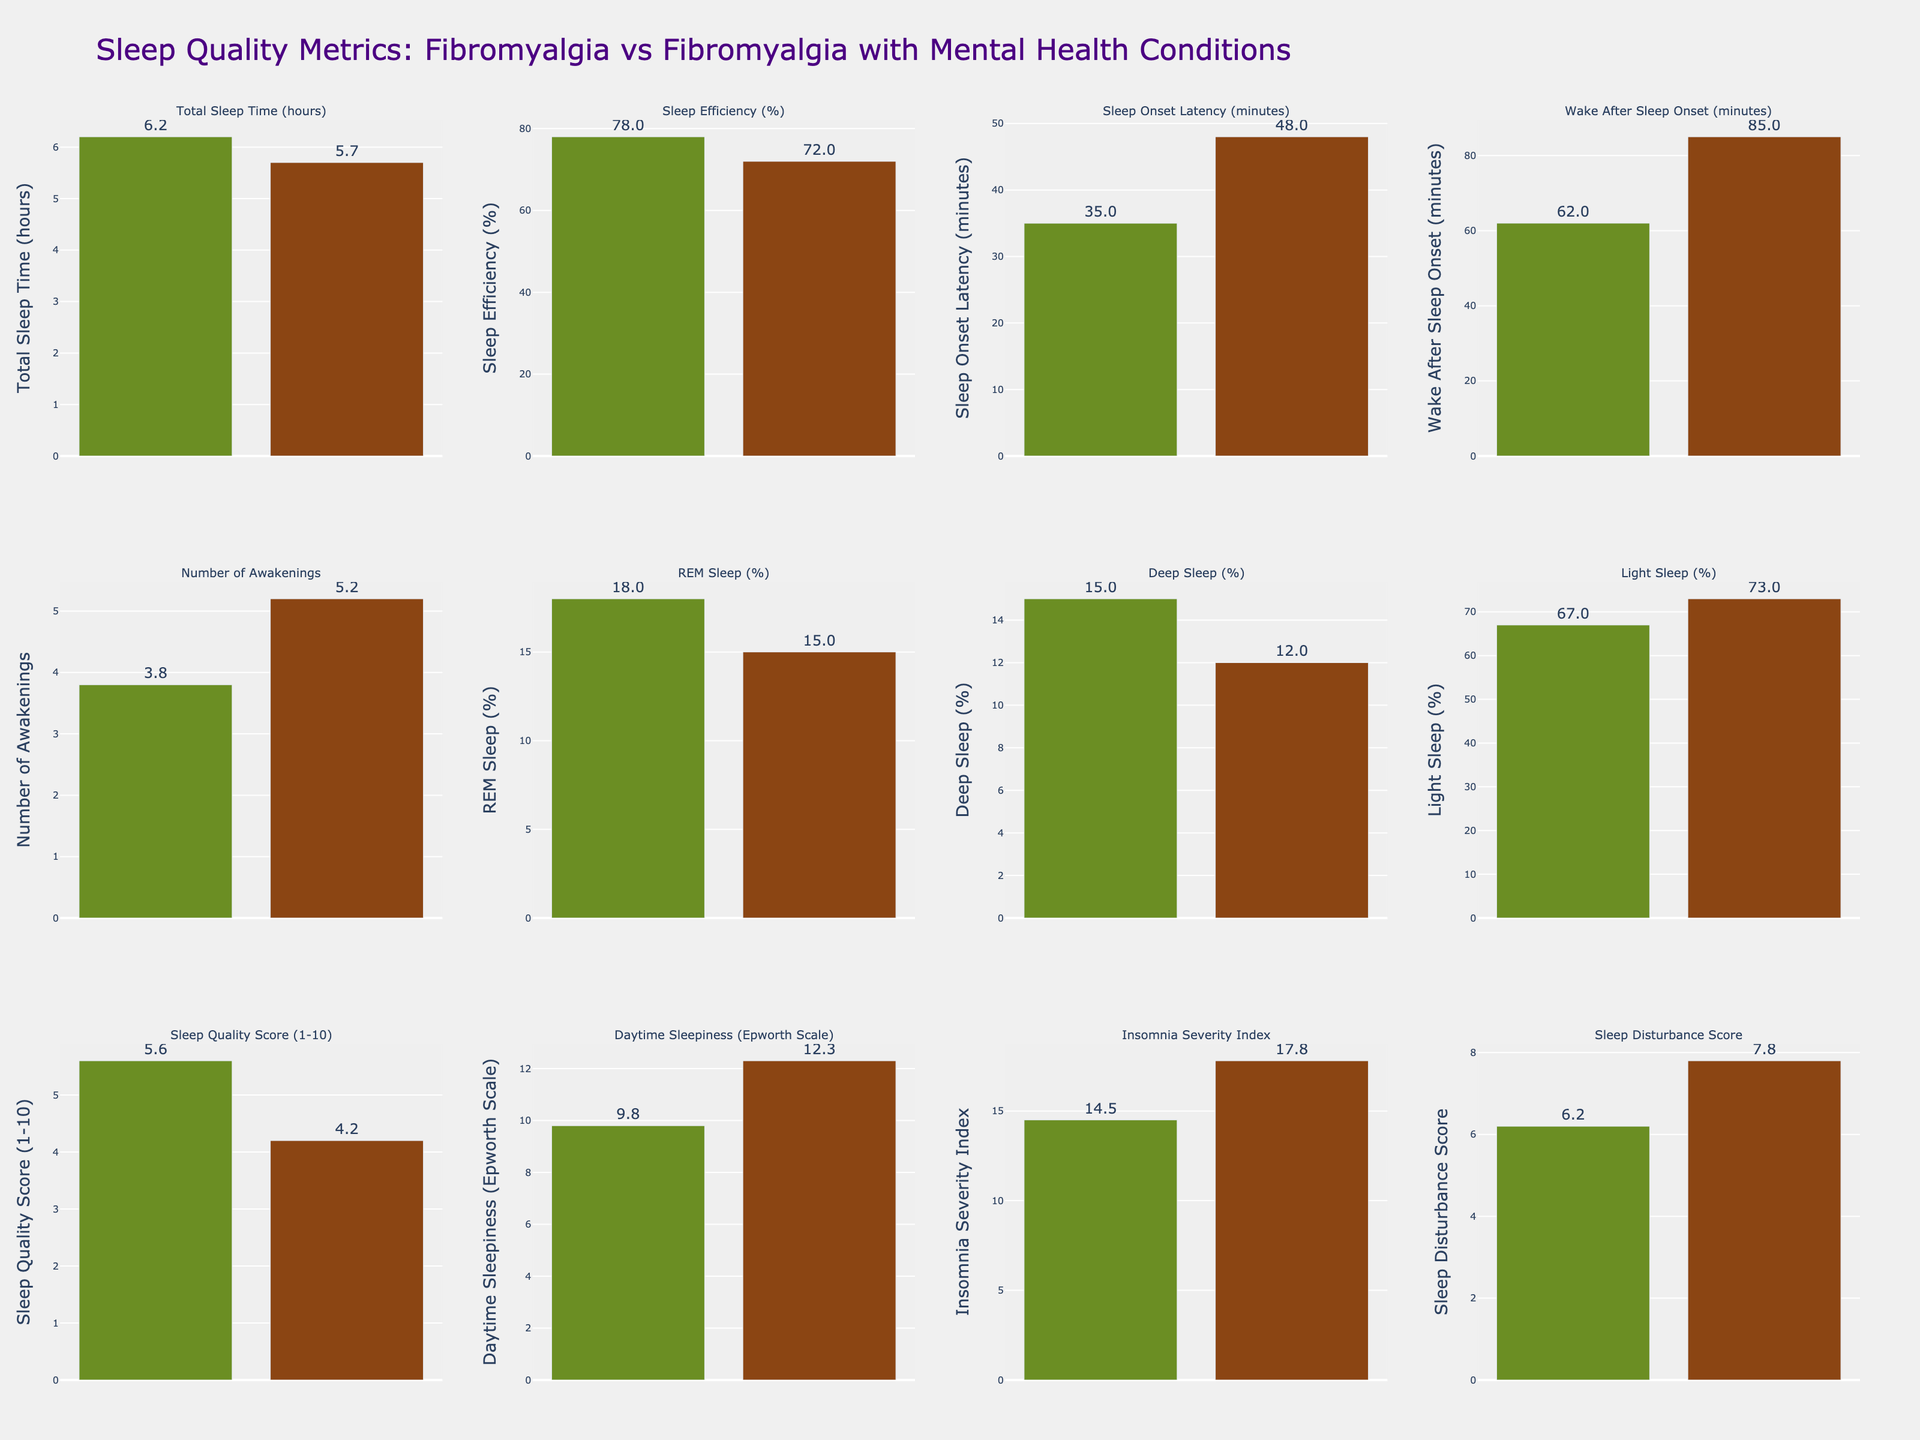Which group reports a higher Sleep Quality Score? By comparing the height of the bars for the Sleep Quality Score, the Fibromyalgia Only group has a higher value than the group with comorbid mental health conditions.
Answer: Fibromyalgia Only How much greater is the average number of awakenings in the comorbid mental health conditions group compared to the fibromyalgia only group? Subtract the number of awakenings for the Fibromyalgia Only group (3.8) from the number in the comorbid mental health conditions group (5.2).
Answer: 1.4 What is the percentage difference in Sleep Efficiency between the two groups? Calculate the difference in Sleep Efficiency (78% - 72%) and divide by the value for Fibromyalgia Only, then multiply by 100.  (78 - 72) / 78 * 100 = 7.69
Answer: 7.69% Which group has a lower percentage of REM Sleep? By comparing the heights of the bars for REM Sleep, the Fibromyalgia with comorbid mental health conditions group has a lower value.
Answer: Fibromyalgia with comorbid mental health conditions Is there a notable difference in total sleep time between the two groups? The total sleep time for Fibromyalgia Only is 6.2 hours, and for the comorbid mental health condition group it is 5.7 hours. The difference is 0.5 hours.
Answer: Yes Are there any sleep quality metrics where the two groups have equal values? Review each metric’s bars to see if they are of equal height. There are no metrics where the two groups have equal values.
Answer: No Which group experiences higher daytime sleepiness according to the Epworth Scale? The bar representing Daytime Sleepiness (Epworth Scale) shows a higher value for the comorbid mental health conditions group.
Answer: Fibromyalgia with comorbid mental health conditions What's the sum of the Insomnia Severity Index values for both groups? Add the Insomnia Severity Index for Fibromyalgia Only (14.5) and the comorbid mental health condition group (17.8). 14.5 + 17.8 = 32.3
Answer: 32.3 How many more minutes of Wake After Sleep Onset do patients with comorbid mental health conditions experience compared to those with only fibromyalgia? Subtract the Wake After Sleep Onset minutes for Fibromyalgia Only (62) from the value for comorbid mental health conditions (85). 85 - 62 = 23
Answer: 23 minutes Which metric shows the greatest difference between the two groups? By visually inspecting all the bars, Sleep Onset Latency shows the greatest difference (48 minutes for comorbid group and 35 minutes for fibro only). The difference is 13 minutes.
Answer: Sleep Onset Latency 